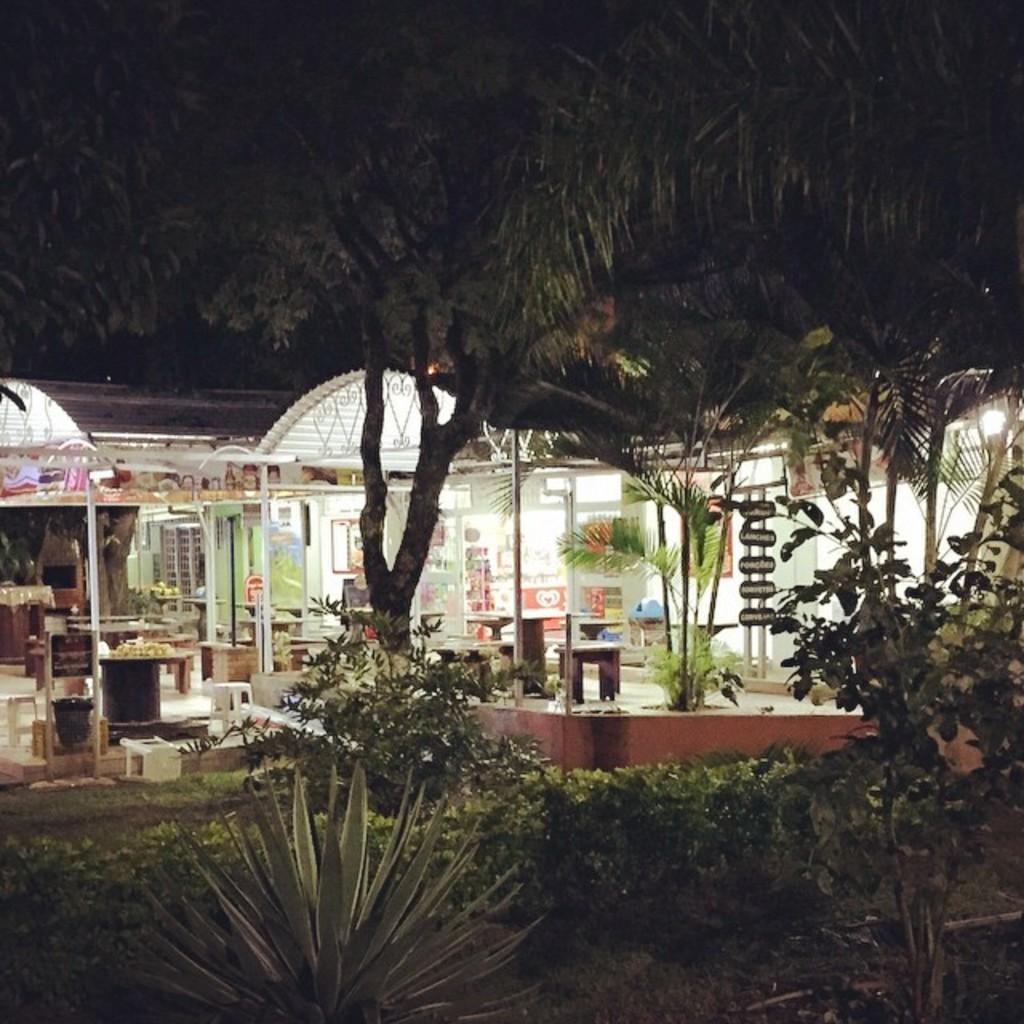Could you give a brief overview of what you see in this image? In this image I can see the plants and many trees. In the background I can see the shed with boards, tables, benches and the lights. 